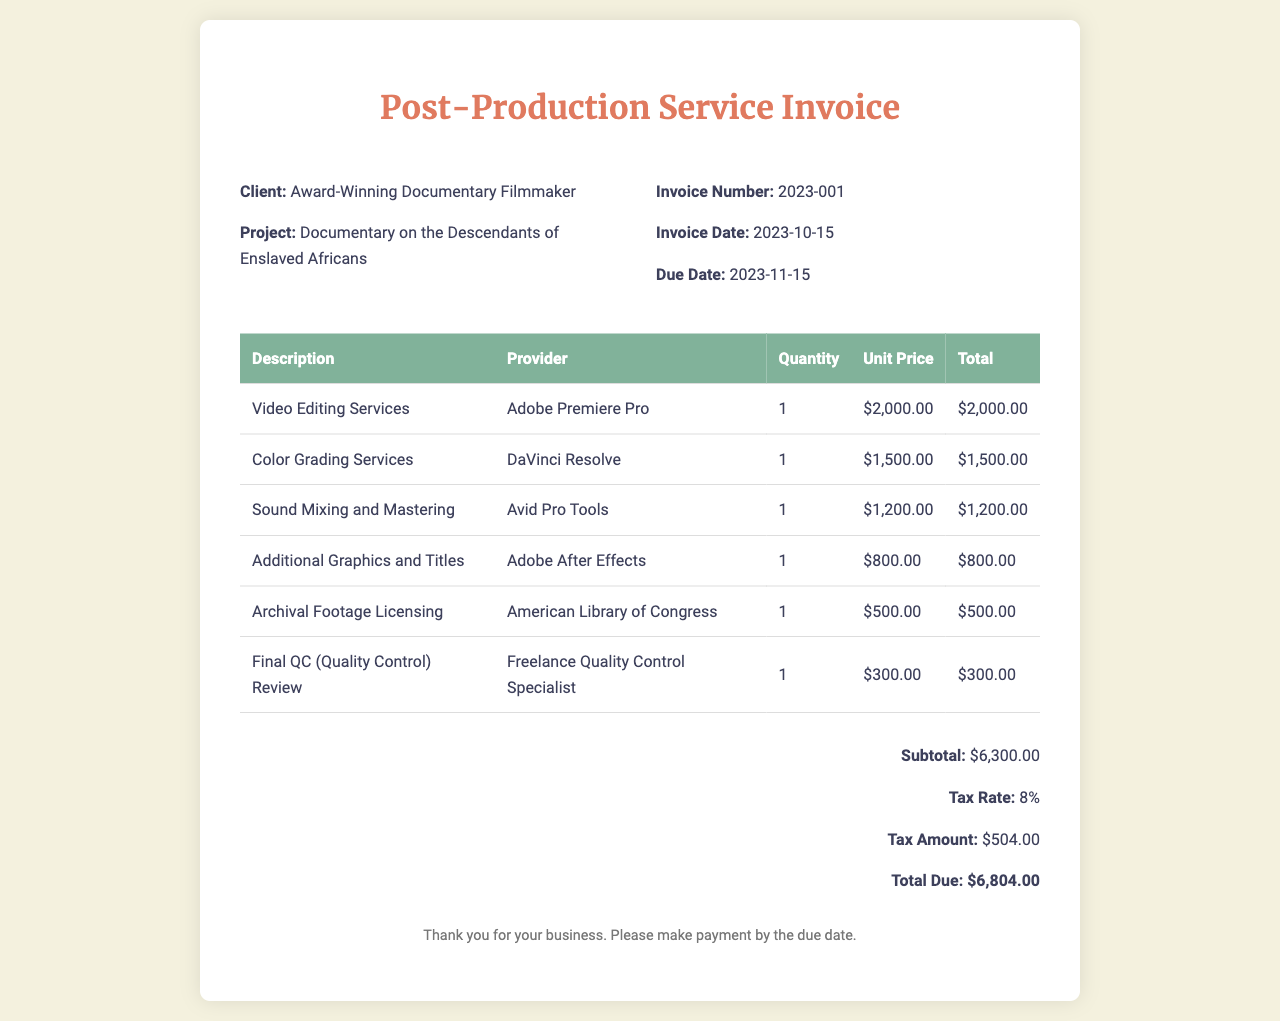What is the invoice number? The invoice number is listed in the invoice details section.
Answer: 2023-001 What is the due date for payment? The due date is mentioned in the invoice details section.
Answer: 2023-11-15 How much is the total due? The total due is calculated at the bottom of the invoice.
Answer: $6,804.00 What service uses DaVinci Resolve? The document specifies the service associated with DaVinci Resolve in the itemized list.
Answer: Color Grading Services What percentage is the tax rate? The tax rate is stated in the total section of the invoice.
Answer: 8% How many different services are listed in the invoice? The number of services can be counted from the itemized table.
Answer: 6 What is the total for Sound Mixing and Mastering? The total for this specific service is found in the itemized table.
Answer: $1,200.00 Who provided the Video Editing Services? The provider for this service is stated in the corresponding row of the table.
Answer: Adobe Premiere Pro What is included in the subtotal before tax? The subtotal is provided in the total section before tax is added.
Answer: $6,300.00 